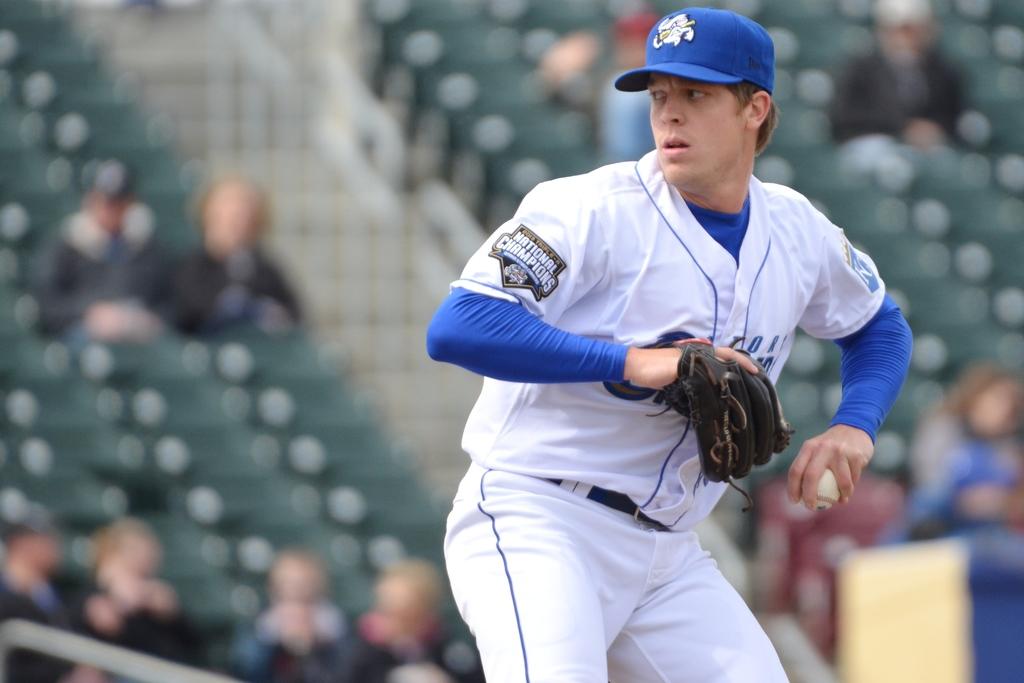What letter is on the sleeve on right?
Offer a terse response. K. What championship is this man playing in?
Offer a terse response. National. 